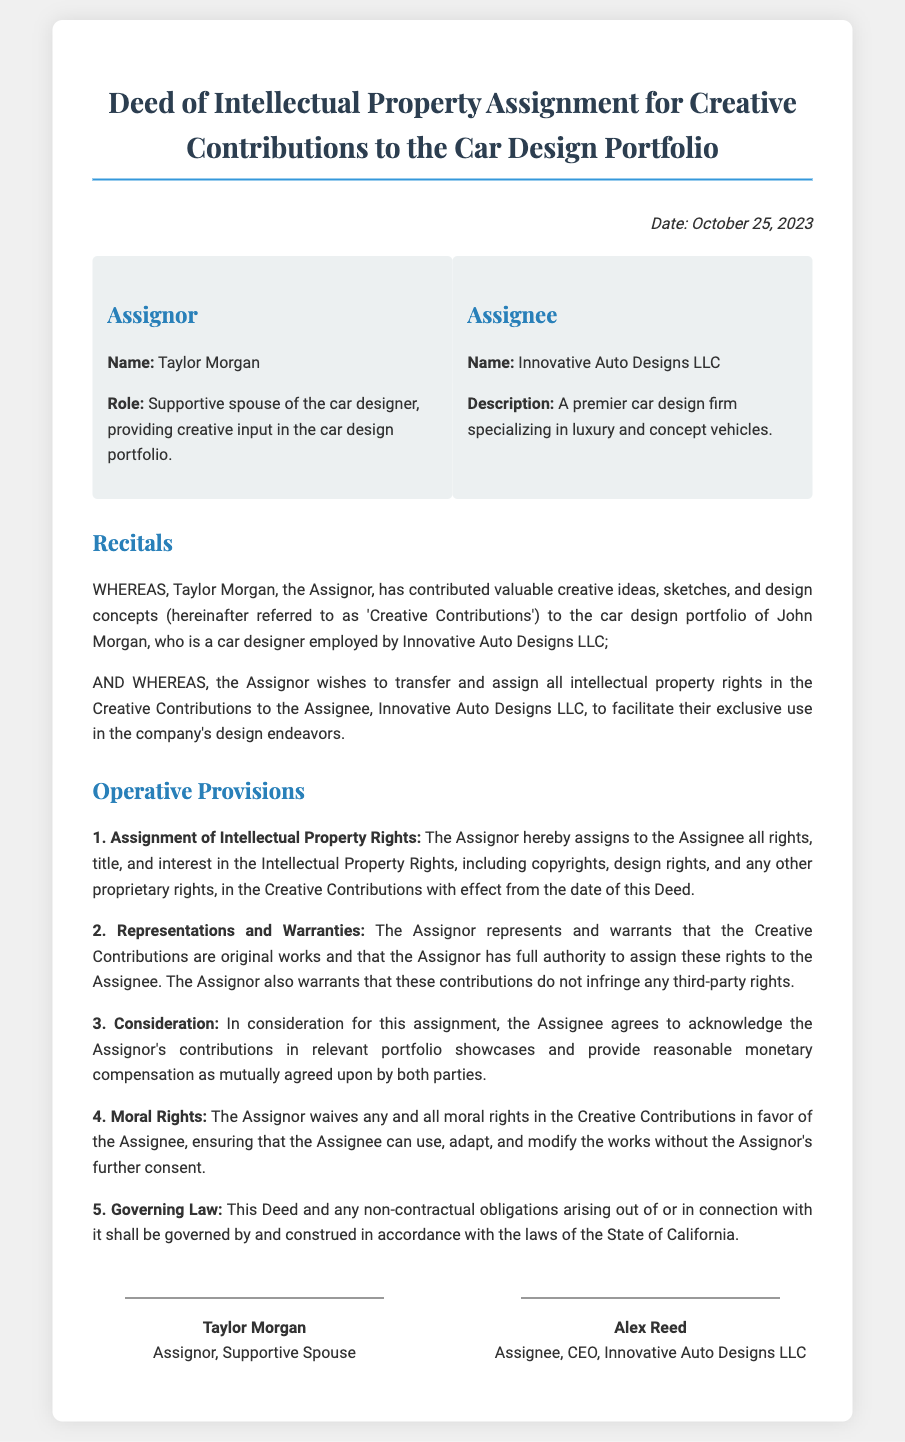what is the date of the deed? The date of the deed is explicitly stated at the top of the document, which reads "Date: October 25, 2023."
Answer: October 25, 2023 who is the assignor? The assignor is identified as "Taylor Morgan" in the document, providing their name clearly in the assignor section.
Answer: Taylor Morgan what is the name of the assignee? The assignee is referred to as "Innovative Auto Designs LLC" in the corresponding section of the document.
Answer: Innovative Auto Designs LLC what is the title of the document? The title of the document is shown prominently at the beginning, stating "Deed of Intellectual Property Assignment for Creative Contributions to the Car Design Portfolio."
Answer: Deed of Intellectual Property Assignment for Creative Contributions to the Car Design Portfolio what is the consideration from the assignee? The consideration details are provided in the operative provisions, specifying that the assignee agrees to acknowledge contributions and provide compensation.
Answer: Acknowledge contributions and provide reasonable monetary compensation what moral rights does the assignor waive? The document states that the assignor waives their moral rights in the Creative Contributions in favor of the assignee, which allows for modifications.
Answer: Any and all moral rights which state law governs this deed? The governing law section indicates that the deed is governed by and construed in accordance with the laws of the State of California.
Answer: California what role does Taylor Morgan hold? Taylor Morgan’s role is described in the assignor section, where it specifies that they are the supportive spouse of the car designer.
Answer: Supportive spouse of the car designer 